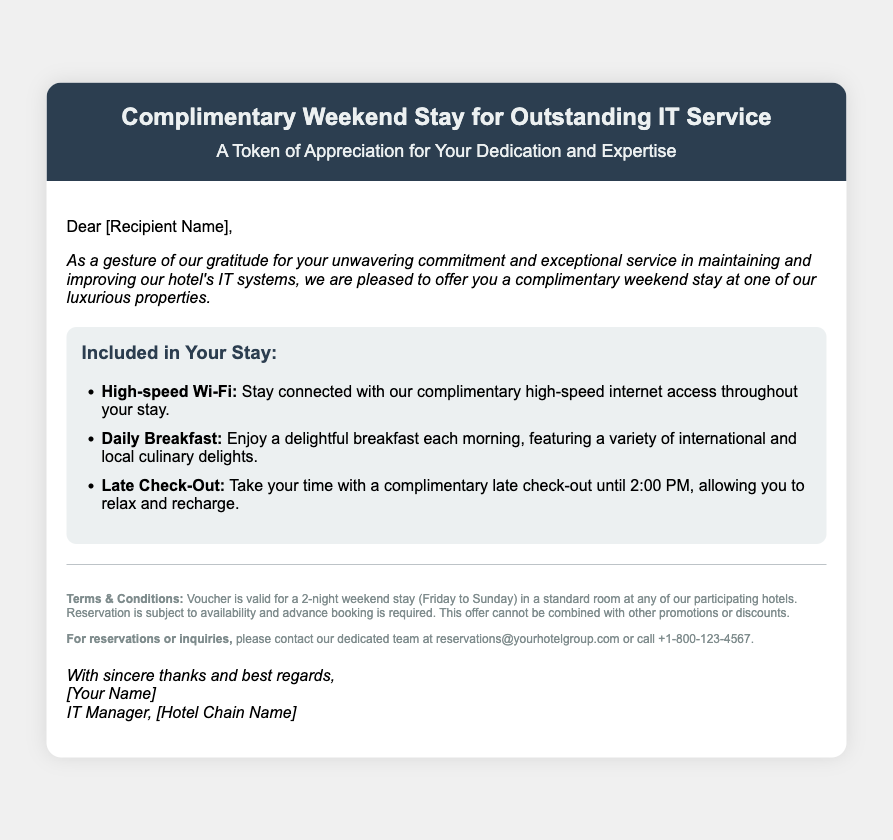What is the title of the voucher? The title clearly states the offer presented in the document.
Answer: Complimentary Weekend Stay for Outstanding IT Service What amenities are included in the stay? The document lists specific amenities that are part of the voucher offer.
Answer: High-speed Wi-Fi, Daily Breakfast, Late Check-Out What time is the late check-out? The document provides specific details regarding the late check-out benefit.
Answer: 2:00 PM Who should be contacted for reservations? The voucher provides a contact point for further inquiries regarding the offer.
Answer: reservations@yourhotelgroup.com How many nights is the voucher valid for? The document specifies the duration of the stay that the voucher entitles.
Answer: 2 nights What is the intended recipient's appreciation for? The document states the reason for issuing the voucher.
Answer: Outstanding IT Service What is the deadline for making a reservation? The document implies a need for advance booking but doesn't specify a deadline.
Answer: Advance booking is required On which days are stays typically valid? The document indicates the specific time frame for the valid stay period.
Answer: Friday to Sunday What is the footer's font size? The footer mentions specific design attributes relevant to the document's layout.
Answer: 12px 